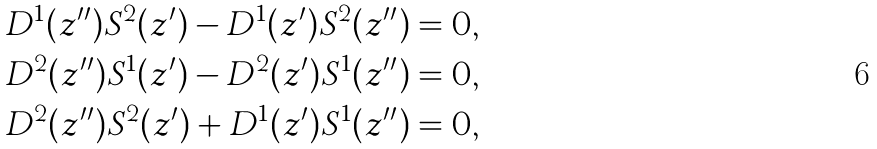Convert formula to latex. <formula><loc_0><loc_0><loc_500><loc_500>D ^ { 1 } ( z ^ { \prime \prime } ) S ^ { 2 } ( z ^ { \prime } ) - D ^ { 1 } ( z ^ { \prime } ) S ^ { 2 } ( z ^ { \prime \prime } ) = 0 , \\ D ^ { 2 } ( z ^ { \prime \prime } ) S ^ { 1 } ( z ^ { \prime } ) - D ^ { 2 } ( z ^ { \prime } ) S ^ { 1 } ( z ^ { \prime \prime } ) = 0 , \\ D ^ { 2 } ( z ^ { \prime \prime } ) S ^ { 2 } ( z ^ { \prime } ) + D ^ { 1 } ( z ^ { \prime } ) S ^ { 1 } ( z ^ { \prime \prime } ) = 0 ,</formula> 